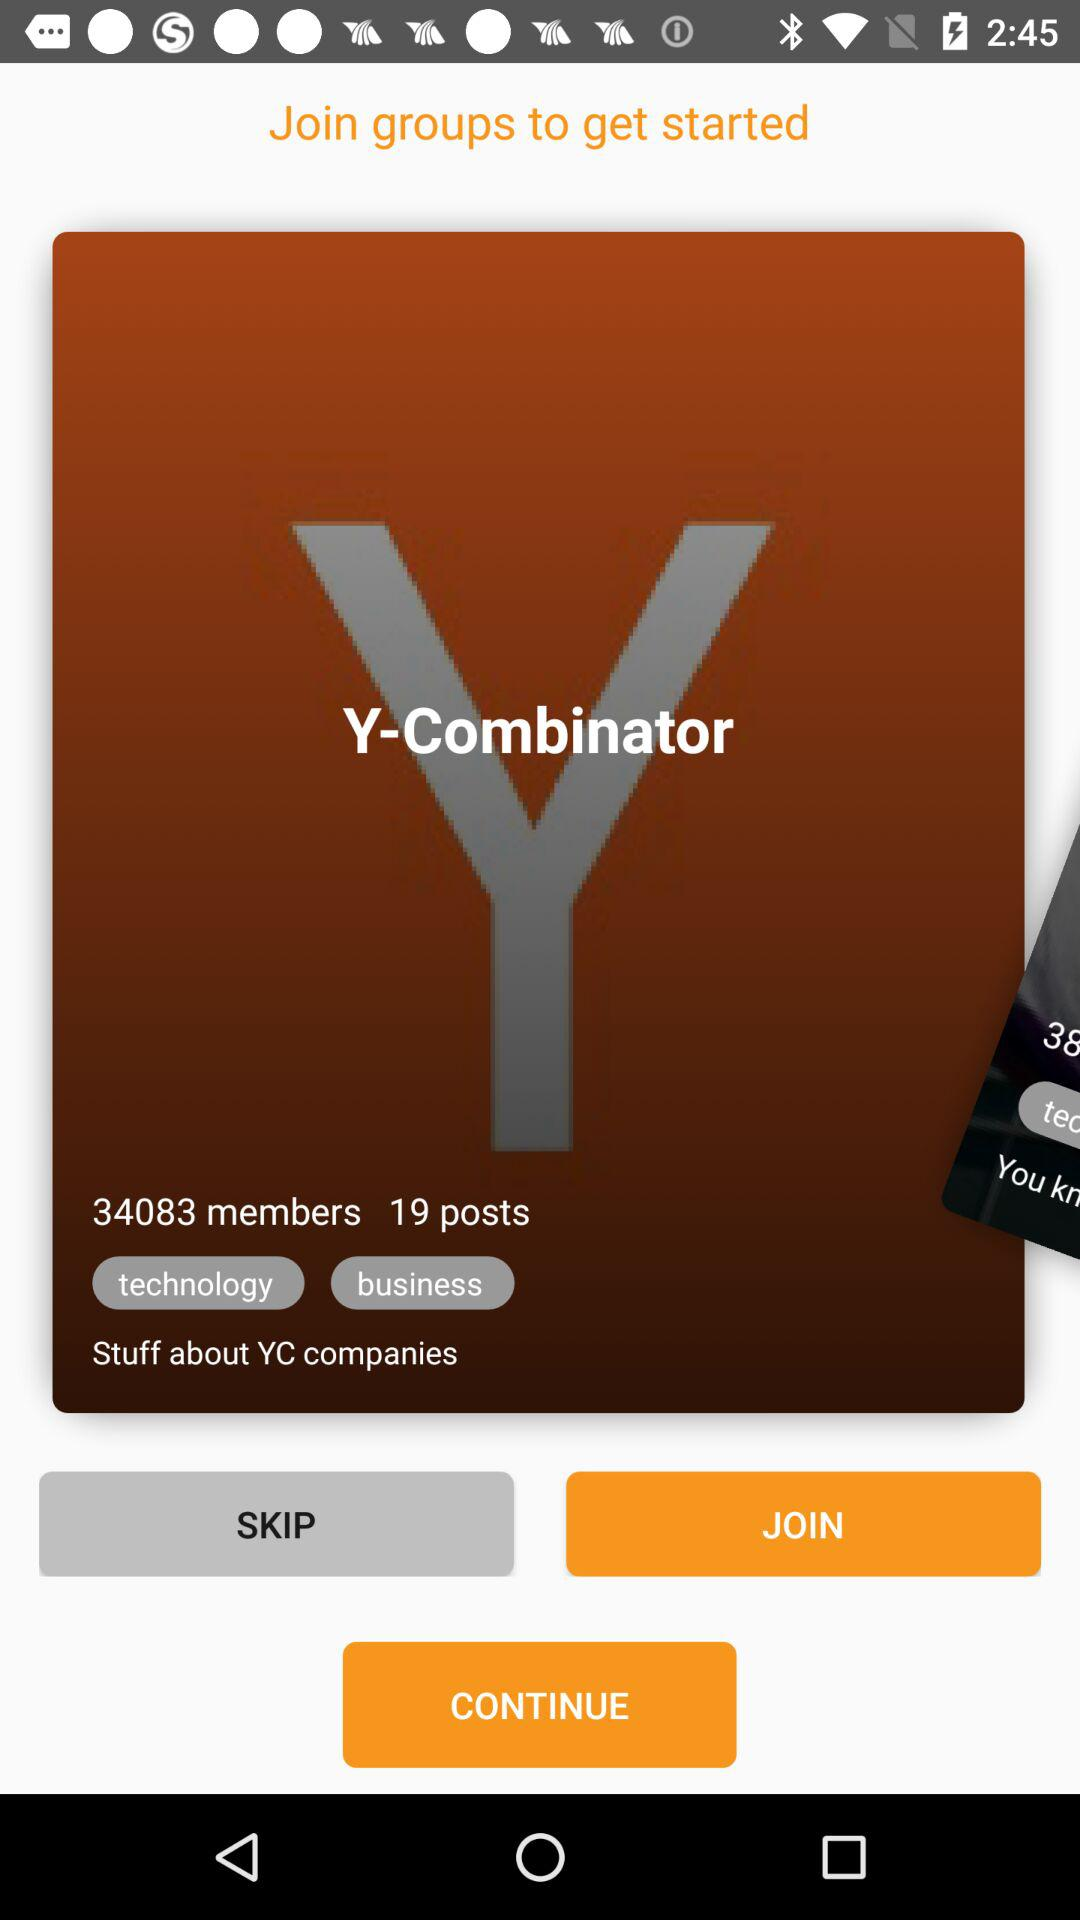What type of stuff will get into the group?
When the provided information is insufficient, respond with <no answer>. <no answer> 